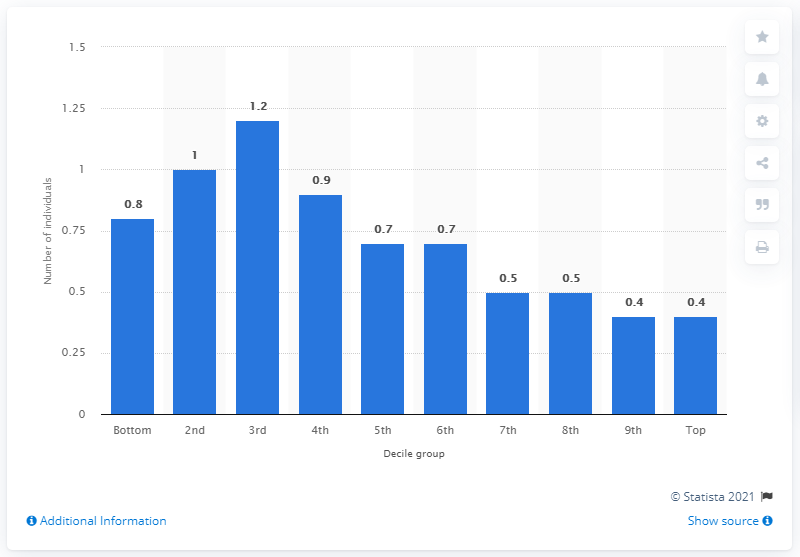Specify some key components in this picture. The average number of children per household in the third decile was 1.2. 